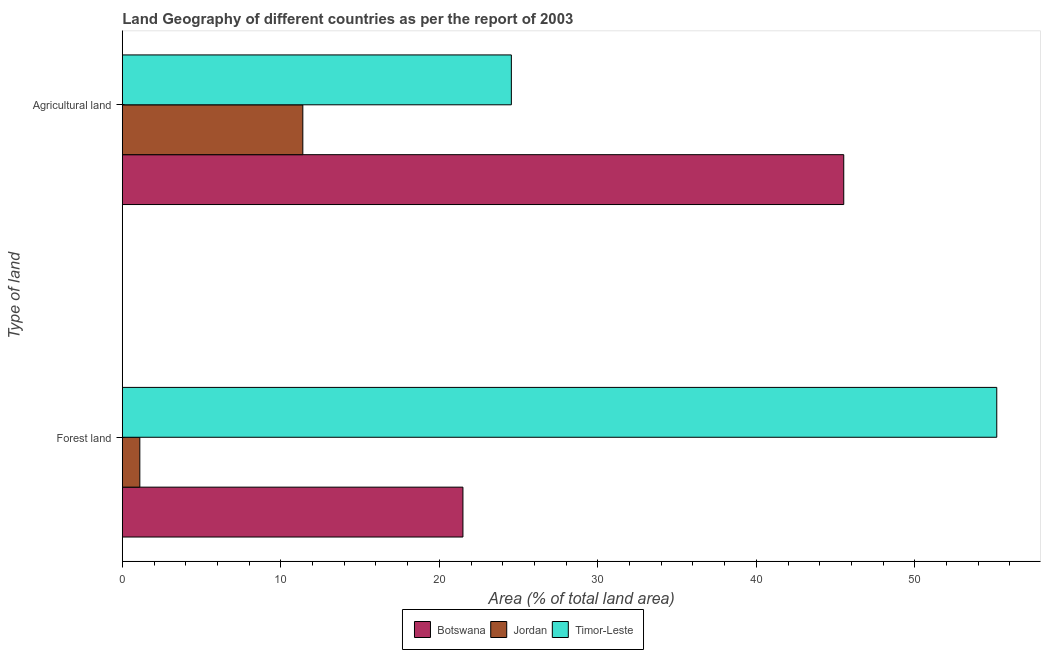How many different coloured bars are there?
Your answer should be compact. 3. Are the number of bars on each tick of the Y-axis equal?
Give a very brief answer. Yes. How many bars are there on the 2nd tick from the bottom?
Give a very brief answer. 3. What is the label of the 1st group of bars from the top?
Your answer should be compact. Agricultural land. What is the percentage of land area under forests in Botswana?
Keep it short and to the point. 21.49. Across all countries, what is the maximum percentage of land area under forests?
Your response must be concise. 55.17. Across all countries, what is the minimum percentage of land area under agriculture?
Provide a short and direct response. 11.39. In which country was the percentage of land area under agriculture maximum?
Keep it short and to the point. Botswana. In which country was the percentage of land area under forests minimum?
Ensure brevity in your answer.  Jordan. What is the total percentage of land area under agriculture in the graph?
Your answer should be very brief. 81.45. What is the difference between the percentage of land area under forests in Botswana and that in Timor-Leste?
Provide a succinct answer. -33.68. What is the difference between the percentage of land area under agriculture in Jordan and the percentage of land area under forests in Timor-Leste?
Offer a very short reply. -43.78. What is the average percentage of land area under forests per country?
Provide a succinct answer. 25.92. What is the difference between the percentage of land area under agriculture and percentage of land area under forests in Jordan?
Your answer should be compact. 10.28. What is the ratio of the percentage of land area under forests in Timor-Leste to that in Botswana?
Give a very brief answer. 2.57. In how many countries, is the percentage of land area under agriculture greater than the average percentage of land area under agriculture taken over all countries?
Keep it short and to the point. 1. What does the 3rd bar from the top in Agricultural land represents?
Keep it short and to the point. Botswana. What does the 1st bar from the bottom in Agricultural land represents?
Offer a very short reply. Botswana. How many bars are there?
Provide a succinct answer. 6. Does the graph contain any zero values?
Give a very brief answer. No. Does the graph contain grids?
Provide a succinct answer. No. How are the legend labels stacked?
Your answer should be compact. Horizontal. What is the title of the graph?
Make the answer very short. Land Geography of different countries as per the report of 2003. What is the label or title of the X-axis?
Provide a succinct answer. Area (% of total land area). What is the label or title of the Y-axis?
Make the answer very short. Type of land. What is the Area (% of total land area) in Botswana in Forest land?
Your response must be concise. 21.49. What is the Area (% of total land area) in Jordan in Forest land?
Provide a succinct answer. 1.1. What is the Area (% of total land area) in Timor-Leste in Forest land?
Ensure brevity in your answer.  55.17. What is the Area (% of total land area) in Botswana in Agricultural land?
Offer a terse response. 45.52. What is the Area (% of total land area) in Jordan in Agricultural land?
Keep it short and to the point. 11.39. What is the Area (% of total land area) in Timor-Leste in Agricultural land?
Provide a short and direct response. 24.55. Across all Type of land, what is the maximum Area (% of total land area) in Botswana?
Your answer should be compact. 45.52. Across all Type of land, what is the maximum Area (% of total land area) in Jordan?
Your answer should be very brief. 11.39. Across all Type of land, what is the maximum Area (% of total land area) of Timor-Leste?
Your answer should be compact. 55.17. Across all Type of land, what is the minimum Area (% of total land area) in Botswana?
Ensure brevity in your answer.  21.49. Across all Type of land, what is the minimum Area (% of total land area) in Jordan?
Keep it short and to the point. 1.1. Across all Type of land, what is the minimum Area (% of total land area) in Timor-Leste?
Ensure brevity in your answer.  24.55. What is the total Area (% of total land area) of Botswana in the graph?
Offer a very short reply. 67.01. What is the total Area (% of total land area) of Jordan in the graph?
Offer a very short reply. 12.49. What is the total Area (% of total land area) of Timor-Leste in the graph?
Give a very brief answer. 79.72. What is the difference between the Area (% of total land area) in Botswana in Forest land and that in Agricultural land?
Make the answer very short. -24.03. What is the difference between the Area (% of total land area) in Jordan in Forest land and that in Agricultural land?
Offer a very short reply. -10.28. What is the difference between the Area (% of total land area) of Timor-Leste in Forest land and that in Agricultural land?
Give a very brief answer. 30.63. What is the difference between the Area (% of total land area) of Botswana in Forest land and the Area (% of total land area) of Jordan in Agricultural land?
Provide a succinct answer. 10.1. What is the difference between the Area (% of total land area) in Botswana in Forest land and the Area (% of total land area) in Timor-Leste in Agricultural land?
Provide a short and direct response. -3.05. What is the difference between the Area (% of total land area) of Jordan in Forest land and the Area (% of total land area) of Timor-Leste in Agricultural land?
Ensure brevity in your answer.  -23.44. What is the average Area (% of total land area) of Botswana per Type of land?
Provide a short and direct response. 33.5. What is the average Area (% of total land area) of Jordan per Type of land?
Make the answer very short. 6.25. What is the average Area (% of total land area) in Timor-Leste per Type of land?
Ensure brevity in your answer.  39.86. What is the difference between the Area (% of total land area) in Botswana and Area (% of total land area) in Jordan in Forest land?
Your answer should be compact. 20.39. What is the difference between the Area (% of total land area) in Botswana and Area (% of total land area) in Timor-Leste in Forest land?
Your answer should be very brief. -33.68. What is the difference between the Area (% of total land area) in Jordan and Area (% of total land area) in Timor-Leste in Forest land?
Provide a short and direct response. -54.07. What is the difference between the Area (% of total land area) in Botswana and Area (% of total land area) in Jordan in Agricultural land?
Provide a short and direct response. 34.13. What is the difference between the Area (% of total land area) of Botswana and Area (% of total land area) of Timor-Leste in Agricultural land?
Make the answer very short. 20.97. What is the difference between the Area (% of total land area) in Jordan and Area (% of total land area) in Timor-Leste in Agricultural land?
Provide a short and direct response. -13.16. What is the ratio of the Area (% of total land area) of Botswana in Forest land to that in Agricultural land?
Your answer should be very brief. 0.47. What is the ratio of the Area (% of total land area) of Jordan in Forest land to that in Agricultural land?
Offer a terse response. 0.1. What is the ratio of the Area (% of total land area) of Timor-Leste in Forest land to that in Agricultural land?
Give a very brief answer. 2.25. What is the difference between the highest and the second highest Area (% of total land area) in Botswana?
Your answer should be compact. 24.03. What is the difference between the highest and the second highest Area (% of total land area) in Jordan?
Provide a succinct answer. 10.28. What is the difference between the highest and the second highest Area (% of total land area) in Timor-Leste?
Your response must be concise. 30.63. What is the difference between the highest and the lowest Area (% of total land area) of Botswana?
Give a very brief answer. 24.03. What is the difference between the highest and the lowest Area (% of total land area) in Jordan?
Ensure brevity in your answer.  10.28. What is the difference between the highest and the lowest Area (% of total land area) of Timor-Leste?
Ensure brevity in your answer.  30.63. 